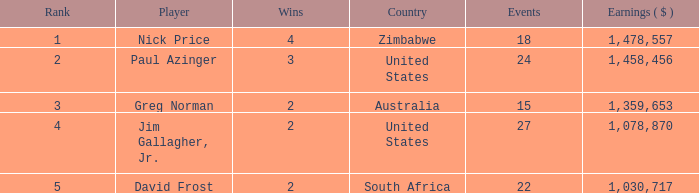How many events are in South Africa? 22.0. 